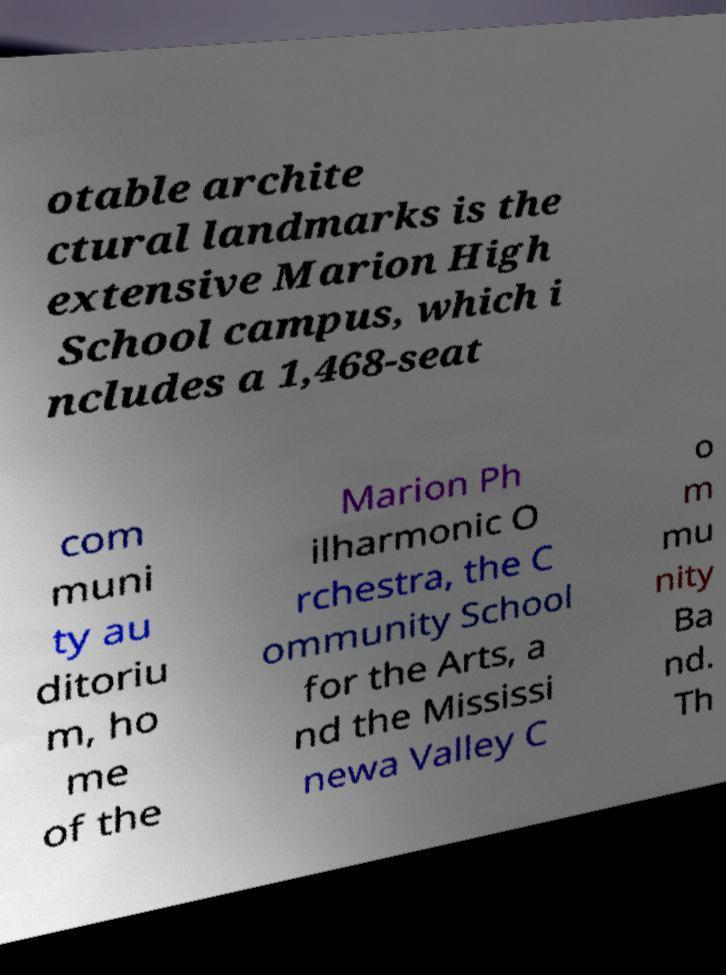Can you accurately transcribe the text from the provided image for me? otable archite ctural landmarks is the extensive Marion High School campus, which i ncludes a 1,468-seat com muni ty au ditoriu m, ho me of the Marion Ph ilharmonic O rchestra, the C ommunity School for the Arts, a nd the Mississi newa Valley C o m mu nity Ba nd. Th 